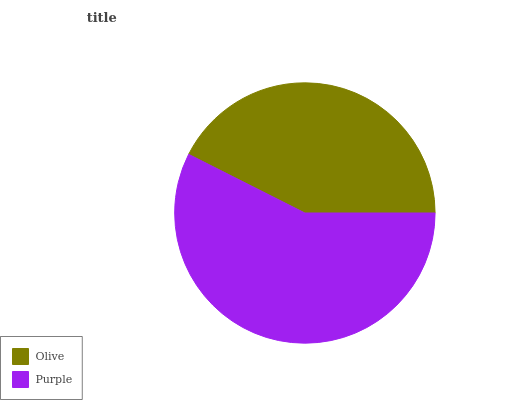Is Olive the minimum?
Answer yes or no. Yes. Is Purple the maximum?
Answer yes or no. Yes. Is Purple the minimum?
Answer yes or no. No. Is Purple greater than Olive?
Answer yes or no. Yes. Is Olive less than Purple?
Answer yes or no. Yes. Is Olive greater than Purple?
Answer yes or no. No. Is Purple less than Olive?
Answer yes or no. No. Is Purple the high median?
Answer yes or no. Yes. Is Olive the low median?
Answer yes or no. Yes. Is Olive the high median?
Answer yes or no. No. Is Purple the low median?
Answer yes or no. No. 